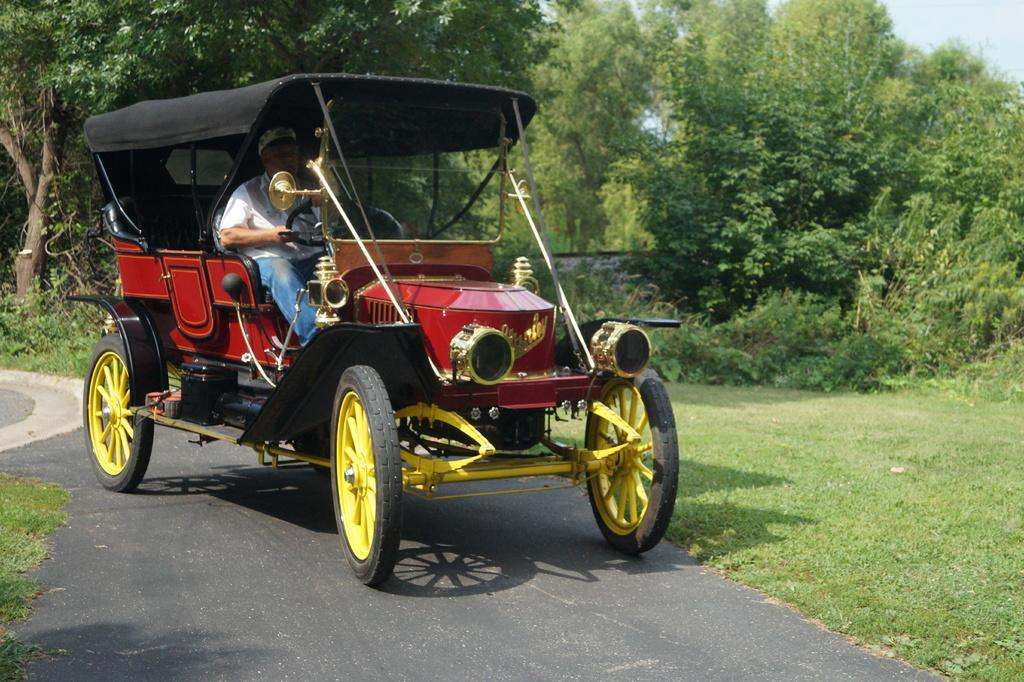What is the man in the image doing? The man is sitting in a cart in the image. What type of natural environment can be seen in the image? There are trees and bushes in the image, which suggests a natural environment. What is visible beneath the man and the cart? The ground is visible in the image. What part of the natural environment is visible above the man and the cart? The sky is visible in the image. How does the man in the image contribute to the growth of society? The image does not provide any information about the man's contribution to society, so it cannot be determined from the image. 